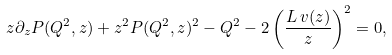<formula> <loc_0><loc_0><loc_500><loc_500>z \partial _ { z } P ( Q ^ { 2 } , z ) + z ^ { 2 } P ( Q ^ { 2 } , z ) ^ { 2 } - Q ^ { 2 } - 2 \left ( \frac { L \, v ( z ) } { z } \right ) ^ { 2 } = 0 ,</formula> 